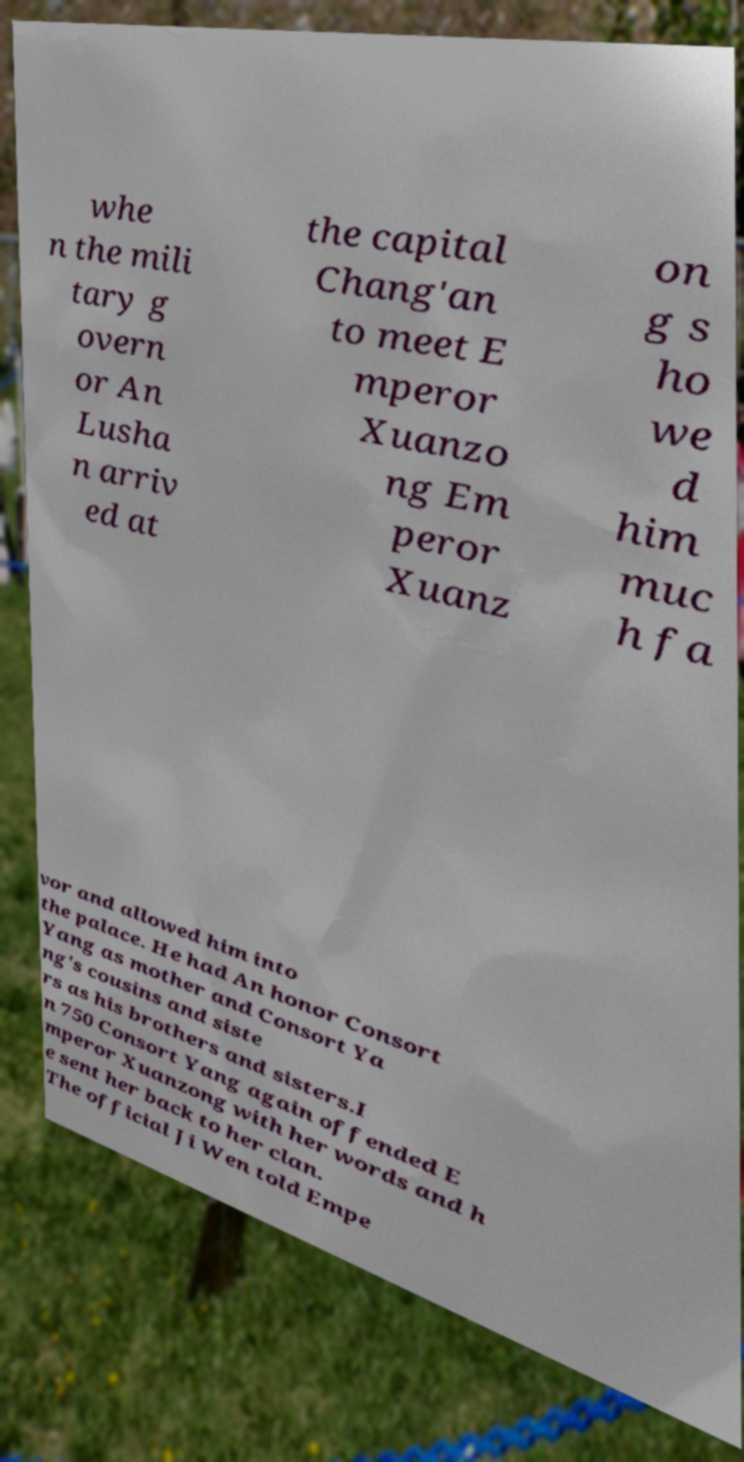Could you assist in decoding the text presented in this image and type it out clearly? whe n the mili tary g overn or An Lusha n arriv ed at the capital Chang'an to meet E mperor Xuanzo ng Em peror Xuanz on g s ho we d him muc h fa vor and allowed him into the palace. He had An honor Consort Yang as mother and Consort Ya ng's cousins and siste rs as his brothers and sisters.I n 750 Consort Yang again offended E mperor Xuanzong with her words and h e sent her back to her clan. The official Ji Wen told Empe 